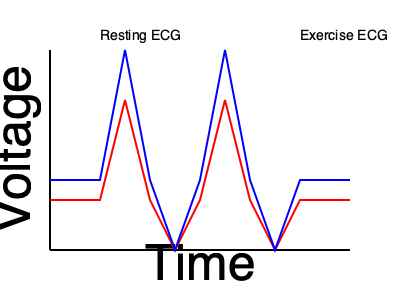As a physiotherapist working with athletes at your local sports club, you're analyzing ECG patterns during different levels of physical activity. Based on the ECG traces shown in the graph, what is the primary difference between the resting ECG (red) and the exercise ECG (blue) that you would explain to your clients? To answer this question, let's analyze the ECG traces step-by-step:

1. Observe the overall pattern: Both ECG traces show the typical PQRST waves of a cardiac cycle.

2. Compare amplitudes:
   a. The resting ECG (red) shows lower amplitude in the QRS complex (the tall spike).
   b. The exercise ECG (blue) shows a higher amplitude in the QRS complex.

3. Analyze the frequency:
   a. The resting ECG has more space between QRS complexes.
   b. The exercise ECG shows QRS complexes closer together.

4. Interpret the changes:
   a. The increased amplitude in the exercise ECG indicates stronger ventricular contractions during physical activity.
   b. The decreased spacing between QRS complexes in the exercise ECG represents an increased heart rate during exercise.

5. Physiological explanation:
   During exercise, the sympathetic nervous system is activated, causing:
   a. Increased force of myocardial contraction (explaining the higher amplitude)
   b. Increased heart rate (explaining the closer spacing of QRS complexes)

The primary difference to explain to clients is the increased heart rate during exercise, as evidenced by the closer spacing of QRS complexes in the blue (exercise) ECG trace compared to the red (resting) ECG trace.
Answer: Increased heart rate during exercise 